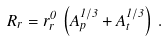Convert formula to latex. <formula><loc_0><loc_0><loc_500><loc_500>R _ { r } = r _ { r } ^ { 0 } \, \left ( A _ { p } ^ { 1 / 3 } + A _ { t } ^ { 1 / 3 } \right ) \, .</formula> 